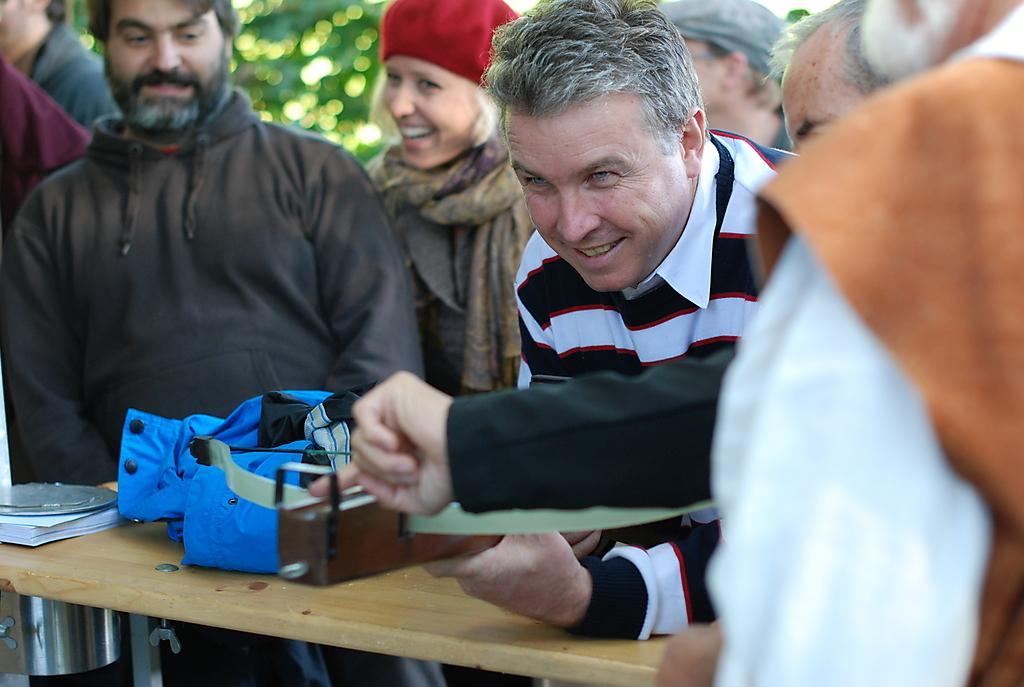What is present in the image? There are persons standing in the image. What can be seen in the background of the image? There is a tree visible in the background of the image. Can you see any rabbits or ants in the image? There are no rabbits or ants visible in the image. What type of wheel is present in the image? There is no wheel present in the image. 